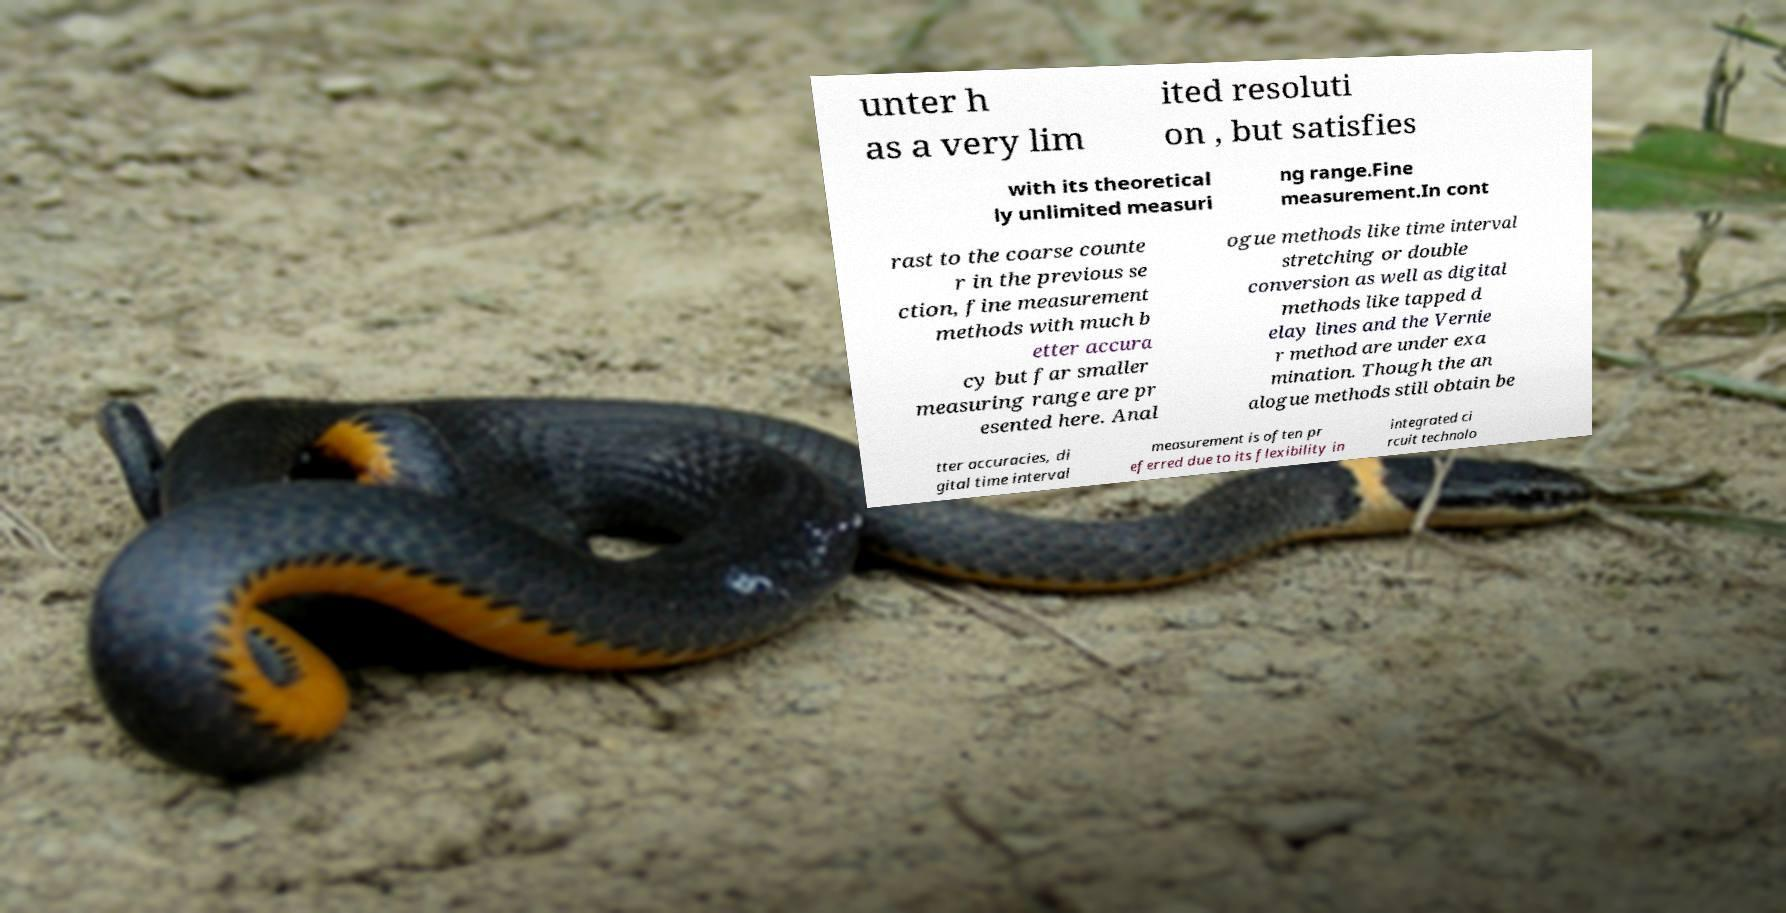For documentation purposes, I need the text within this image transcribed. Could you provide that? unter h as a very lim ited resoluti on , but satisfies with its theoretical ly unlimited measuri ng range.Fine measurement.In cont rast to the coarse counte r in the previous se ction, fine measurement methods with much b etter accura cy but far smaller measuring range are pr esented here. Anal ogue methods like time interval stretching or double conversion as well as digital methods like tapped d elay lines and the Vernie r method are under exa mination. Though the an alogue methods still obtain be tter accuracies, di gital time interval measurement is often pr eferred due to its flexibility in integrated ci rcuit technolo 